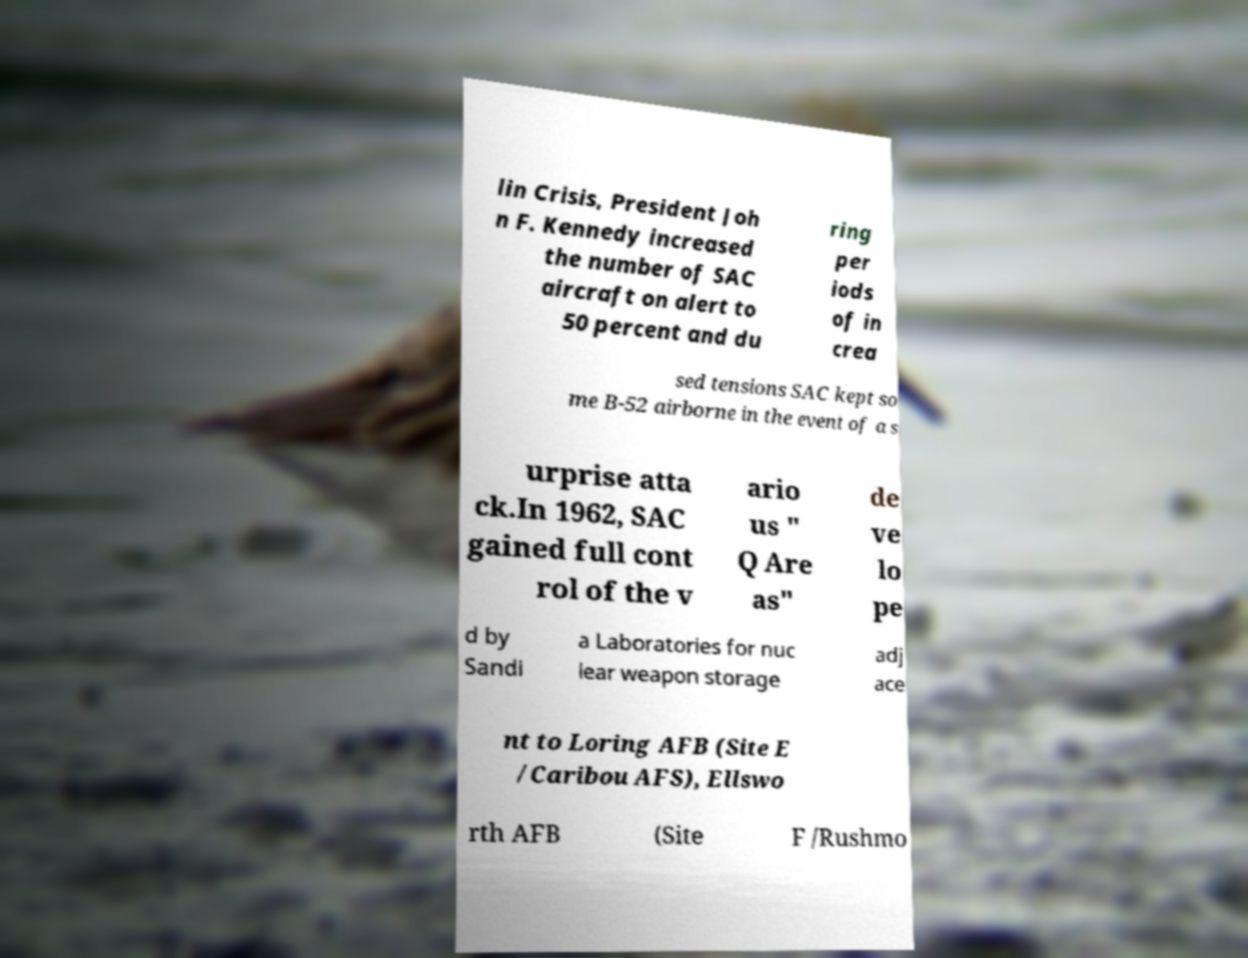I need the written content from this picture converted into text. Can you do that? lin Crisis, President Joh n F. Kennedy increased the number of SAC aircraft on alert to 50 percent and du ring per iods of in crea sed tensions SAC kept so me B-52 airborne in the event of a s urprise atta ck.In 1962, SAC gained full cont rol of the v ario us " Q Are as" de ve lo pe d by Sandi a Laboratories for nuc lear weapon storage adj ace nt to Loring AFB (Site E /Caribou AFS), Ellswo rth AFB (Site F /Rushmo 